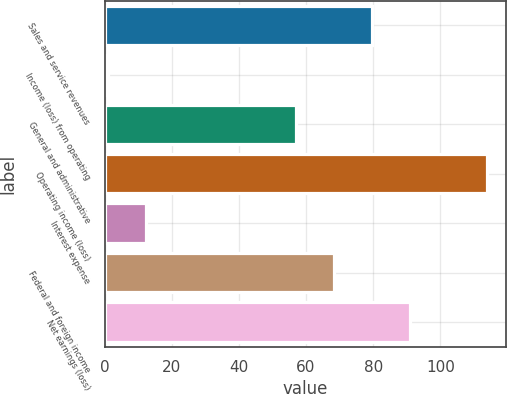Convert chart to OTSL. <chart><loc_0><loc_0><loc_500><loc_500><bar_chart><fcel>Sales and service revenues<fcel>Income (loss) from operating<fcel>General and administrative<fcel>Operating income (loss)<fcel>Interest expense<fcel>Federal and foreign income<fcel>Net earnings (loss)<nl><fcel>79.6<fcel>1<fcel>57<fcel>114<fcel>12.3<fcel>68.3<fcel>90.9<nl></chart> 